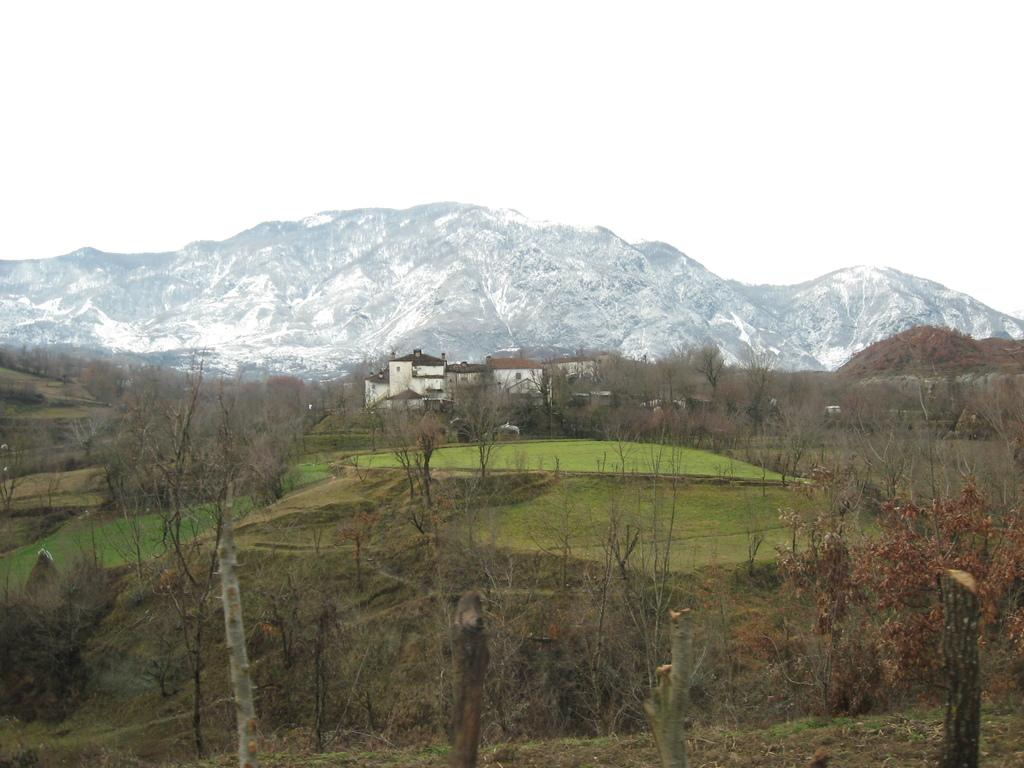What type of view is shown in the image? The image is an outside view. What can be seen at the bottom of the image? There are many trees at the bottom of the image. What is visible in the background of the image? There are buildings and mountains in the background of the image. What is visible at the top of the image? The sky is visible at the top of the image. How many girls are playing in the image? There are no girls present in the image. What type of cover is used to protect the mountains in the image? There is no cover visible in the image; the mountains are not protected by any type of cover. 